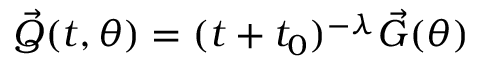Convert formula to latex. <formula><loc_0><loc_0><loc_500><loc_500>\begin{array} { r } { \vec { Q } ( t , \theta ) = ( t + t _ { 0 } ) ^ { - \lambda } \vec { G } ( \theta ) } \end{array}</formula> 